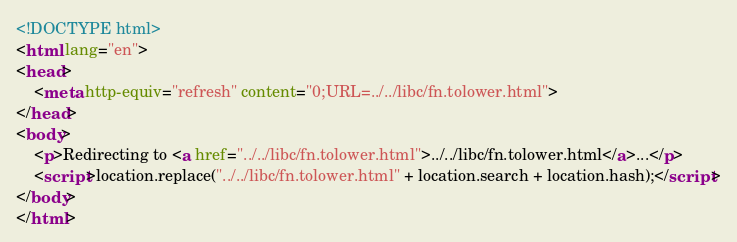<code> <loc_0><loc_0><loc_500><loc_500><_HTML_><!DOCTYPE html>
<html lang="en">
<head>
    <meta http-equiv="refresh" content="0;URL=../../libc/fn.tolower.html">
</head>
<body>
    <p>Redirecting to <a href="../../libc/fn.tolower.html">../../libc/fn.tolower.html</a>...</p>
    <script>location.replace("../../libc/fn.tolower.html" + location.search + location.hash);</script>
</body>
</html></code> 